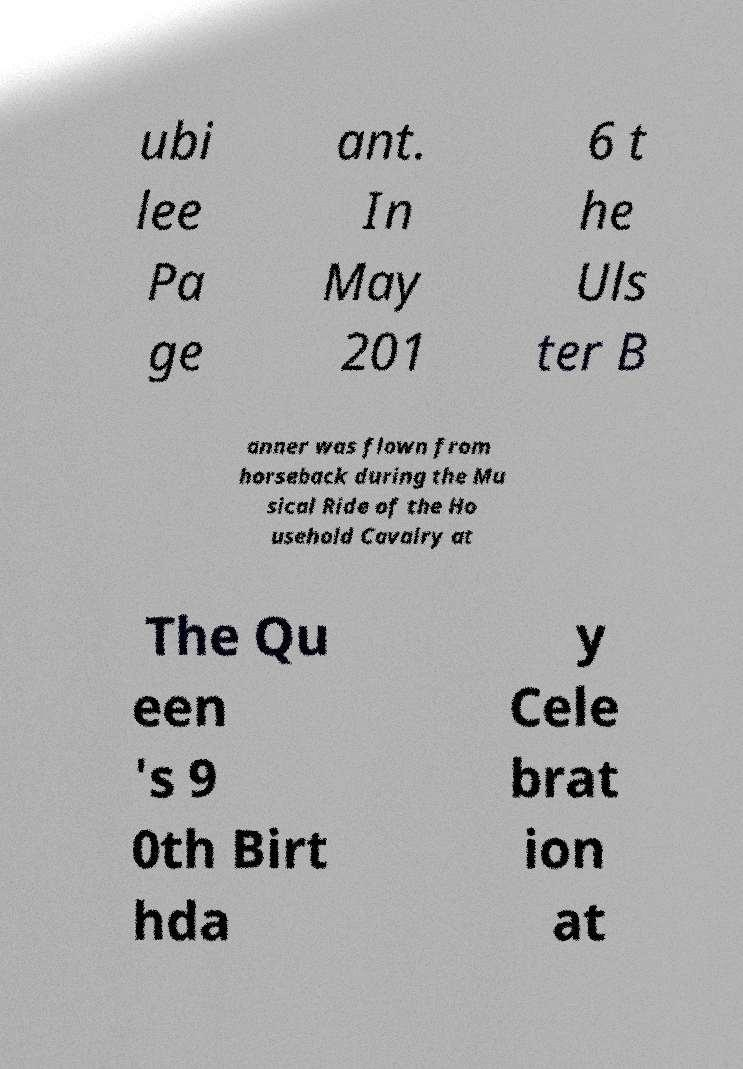Please identify and transcribe the text found in this image. ubi lee Pa ge ant. In May 201 6 t he Uls ter B anner was flown from horseback during the Mu sical Ride of the Ho usehold Cavalry at The Qu een 's 9 0th Birt hda y Cele brat ion at 